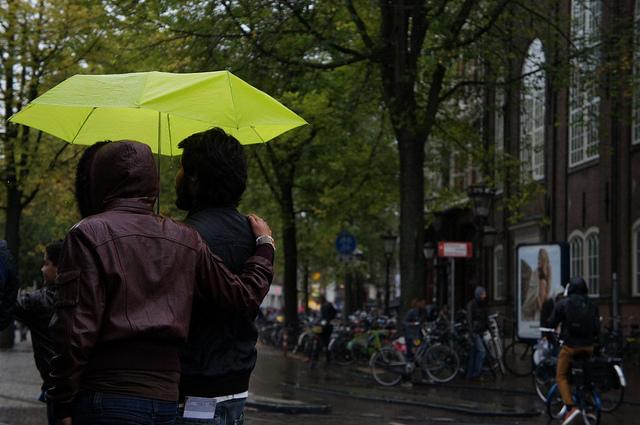How many bikes are there?
Be succinct. Many. How many people are wearing hoodies?
Concise answer only. 1. What shape are the windows?
Concise answer only. Square. How many people are under the umbrella?
Short answer required. 2. Do the men look comfortable?
Write a very short answer. Yes. Does the building have more than one story?
Answer briefly. Yes. Can you see any animals?
Write a very short answer. No. Is this a farmers market?
Concise answer only. No. What color is the umbrella?
Quick response, please. Yellow. How many sections of the umbrella are green?
Give a very brief answer. All. Is it raining?
Write a very short answer. Yes. Is it daytime in the photo?
Quick response, please. Yes. 